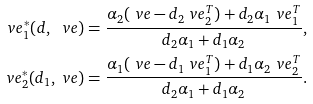<formula> <loc_0><loc_0><loc_500><loc_500>\ v e _ { 1 } ^ { * } ( d , \ v e ) & = \frac { \alpha _ { 2 } ( \ v e - d _ { 2 } \ v e _ { 2 } ^ { T } ) + d _ { 2 } \alpha _ { 1 } \ v e _ { 1 } ^ { T } } { d _ { 2 } \alpha _ { 1 } + d _ { 1 } \alpha _ { 2 } } , \\ \ v e _ { 2 } ^ { * } ( d _ { 1 } , \ v e ) & = \frac { \alpha _ { 1 } ( \ v e - d _ { 1 } \ v e _ { 1 } ^ { T } ) + d _ { 1 } \alpha _ { 2 } \ v e _ { 2 } ^ { T } } { d _ { 2 } \alpha _ { 1 } + d _ { 1 } \alpha _ { 2 } } .</formula> 